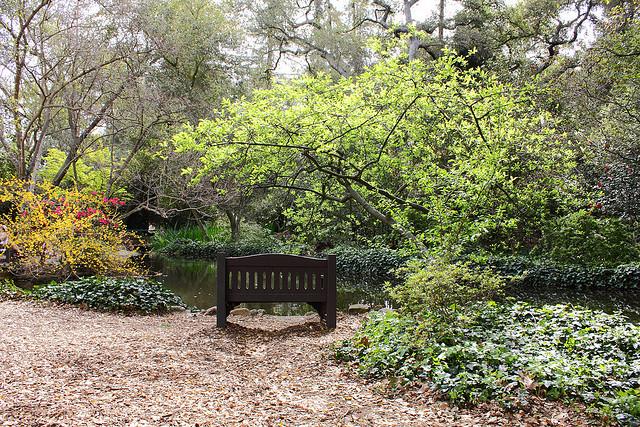Is the bench facing toward the camera?
Keep it brief. No. How many benches are here?
Write a very short answer. 1. Where is the bench located?
Give a very brief answer. In park. 